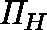Convert formula to latex. <formula><loc_0><loc_0><loc_500><loc_500>\Pi _ { H }</formula> 